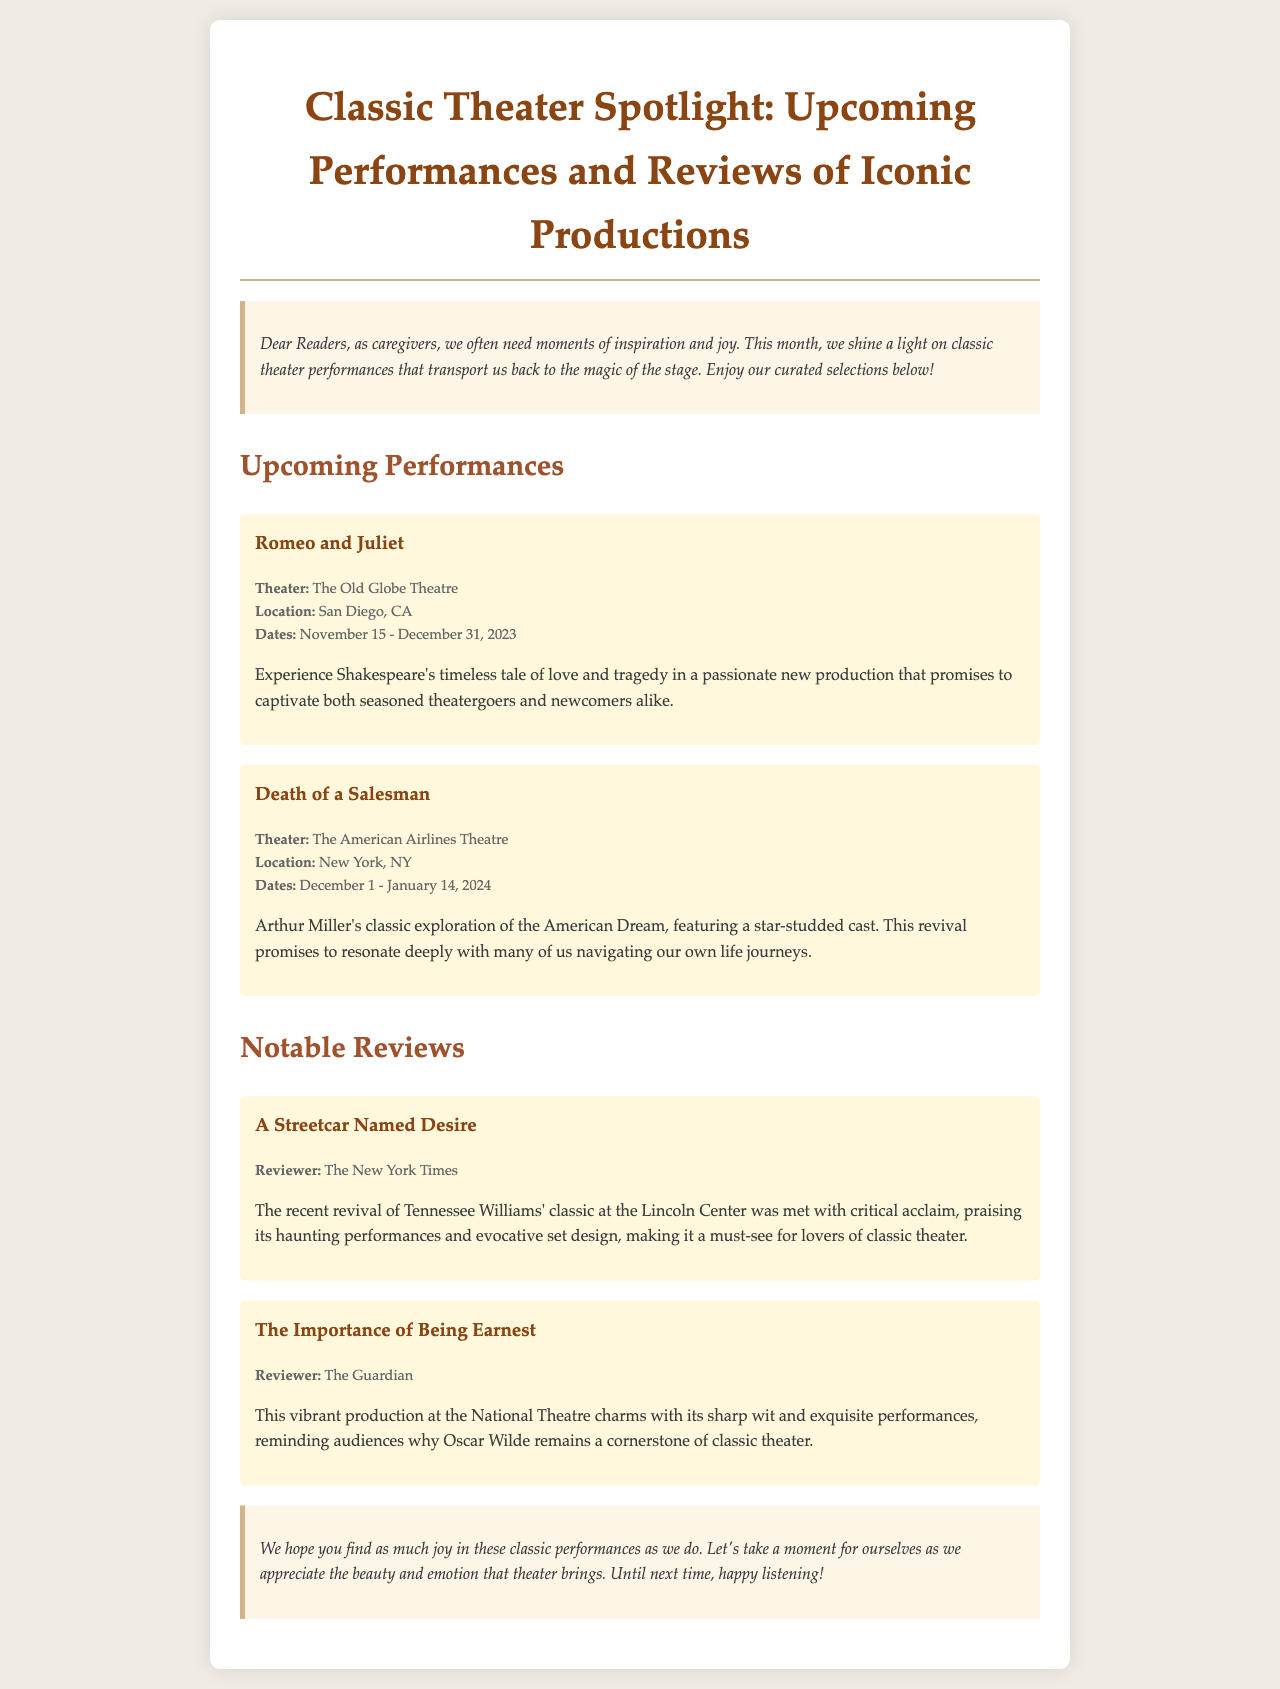What is the title of the newsletter? The title of the newsletter is prominently displayed at the top, which highlights its focus on classic theater performances and reviews.
Answer: Classic Theater Spotlight: Upcoming Performances and Reviews of Iconic Productions Where is "Romeo and Juliet" being performed? The document specifies the location of the performance, mentioning the theater where it will take place.
Answer: The Old Globe Theatre What dates will "Death of a Salesman" be showing? The dates for the performance are listed, indicating when the show will be available to audiences.
Answer: December 1 - January 14, 2024 Who reviewed "A Streetcar Named Desire"? The reviewer is mentioned in the details of the review section, indicating the source of the critique.
Answer: The New York Times What type of play is "Death of a Salesman"? The document describes the play's theme, helping to categorize it based on its content and focus.
Answer: Classic exploration of the American Dream Which theater hosted "The Importance of Being Earnest"? The review specifies where the production was staged, highlighting its location in the context of the review.
Answer: National Theatre What is mentioned as a characteristic of the production of "A Streetcar Named Desire"? The review provides insights into the qualities that stood out in the recent revival, which contribute to its acclaim.
Answer: Haunting performances and evocative set design What is the general tone of the newsletter's introduction? The introduction sets an emotional context, emphasizing the intent behind featuring classic theater.
Answer: Inspiration and joy What is a common theme in the performances highlighted? The performances are focused on deep emotional experiences, connecting them to the personal journeys of the audience.
Answer: Love and tragedy 